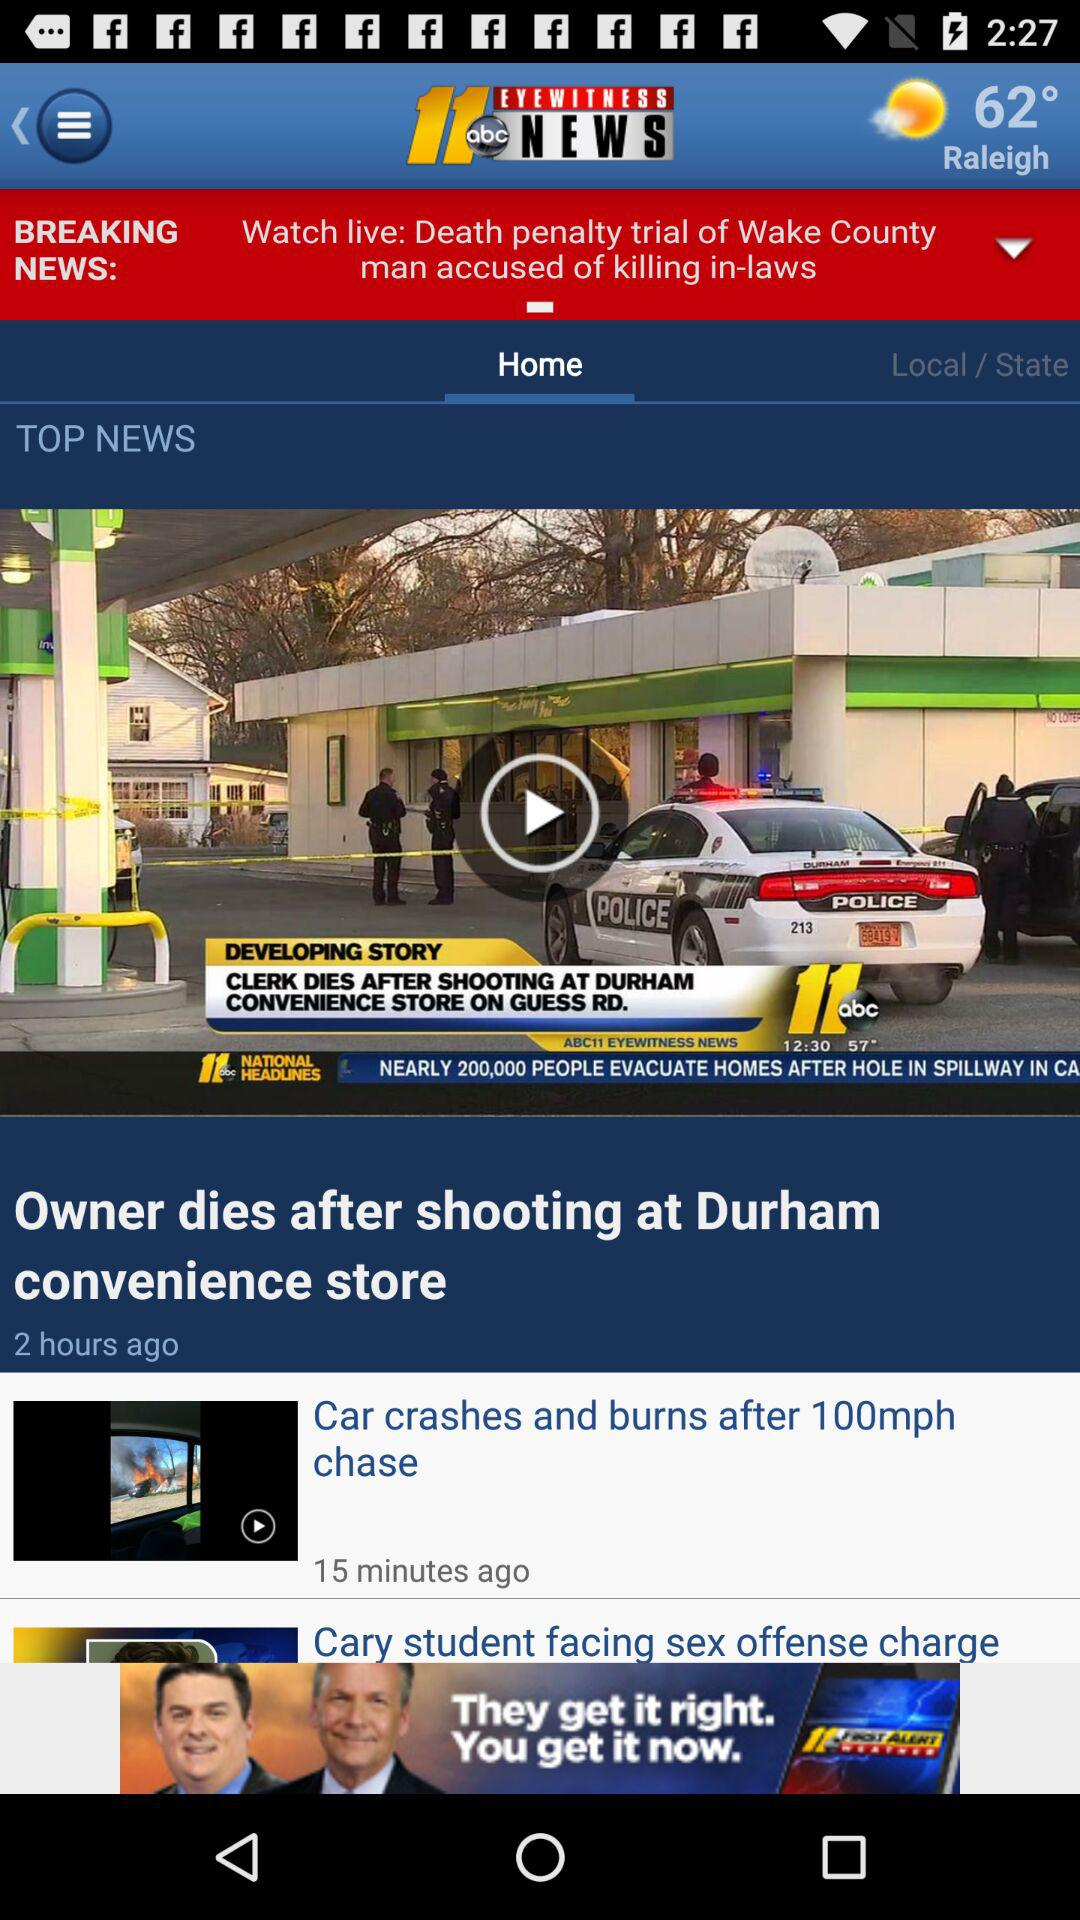When was the video "Owner dies after shooting at Durham convenience store" posted? The video was posted 2 hours ago. 